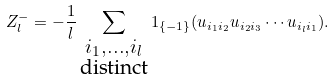<formula> <loc_0><loc_0><loc_500><loc_500>Z _ { l } ^ { - } = - \frac { 1 } { l } \sum _ { \substack { i _ { 1 } , \dots , i _ { l } \\ \text {distinct} } } 1 _ { \{ - 1 \} } ( u _ { i _ { 1 } i _ { 2 } } u _ { i _ { 2 } i _ { 3 } } \cdots u _ { i _ { l } i _ { 1 } } ) .</formula> 